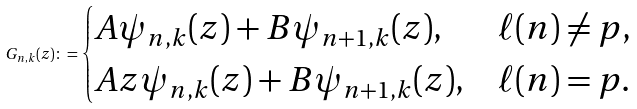<formula> <loc_0><loc_0><loc_500><loc_500>G _ { n , k } ( z ) \colon = \begin{cases} A \psi _ { n , k } ( z ) + B \psi _ { n + 1 , k } ( z ) , & \ell ( n ) \neq p , \\ A z \psi _ { n , k } ( z ) + B \psi _ { n + 1 , k } ( z ) , & \ell ( n ) = p . \end{cases}</formula> 